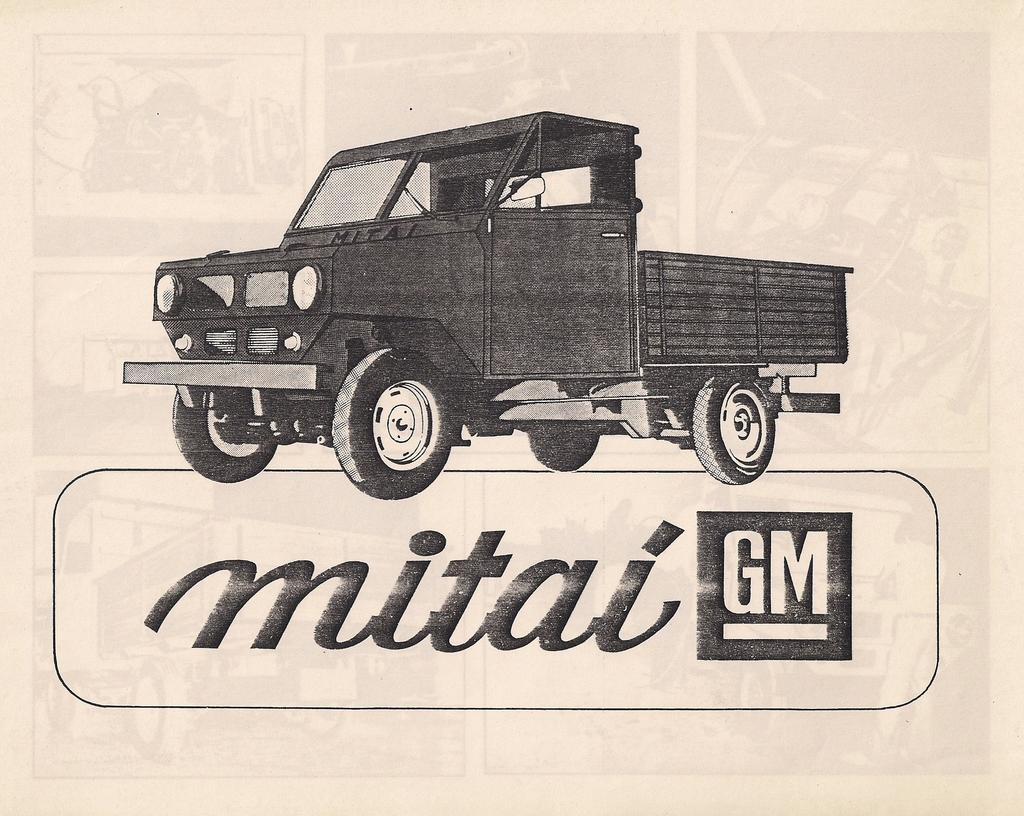What is the main subject of the picture? The main subject of the picture is a sketch of a vehicle. What color is the vehicle in the sketch? The vehicle is in black color. What color is the background of the picture? The background is in cream color. Is there any text present in the picture? Yes, there is some text on the bottom of the picture. How many ladybugs can be seen on the vehicle in the picture? There are no ladybugs present in the picture; it features a sketch of a vehicle with no additional elements. What season is depicted in the picture? The picture does not depict a specific season; it is a sketch of a vehicle with a cream-colored background. 